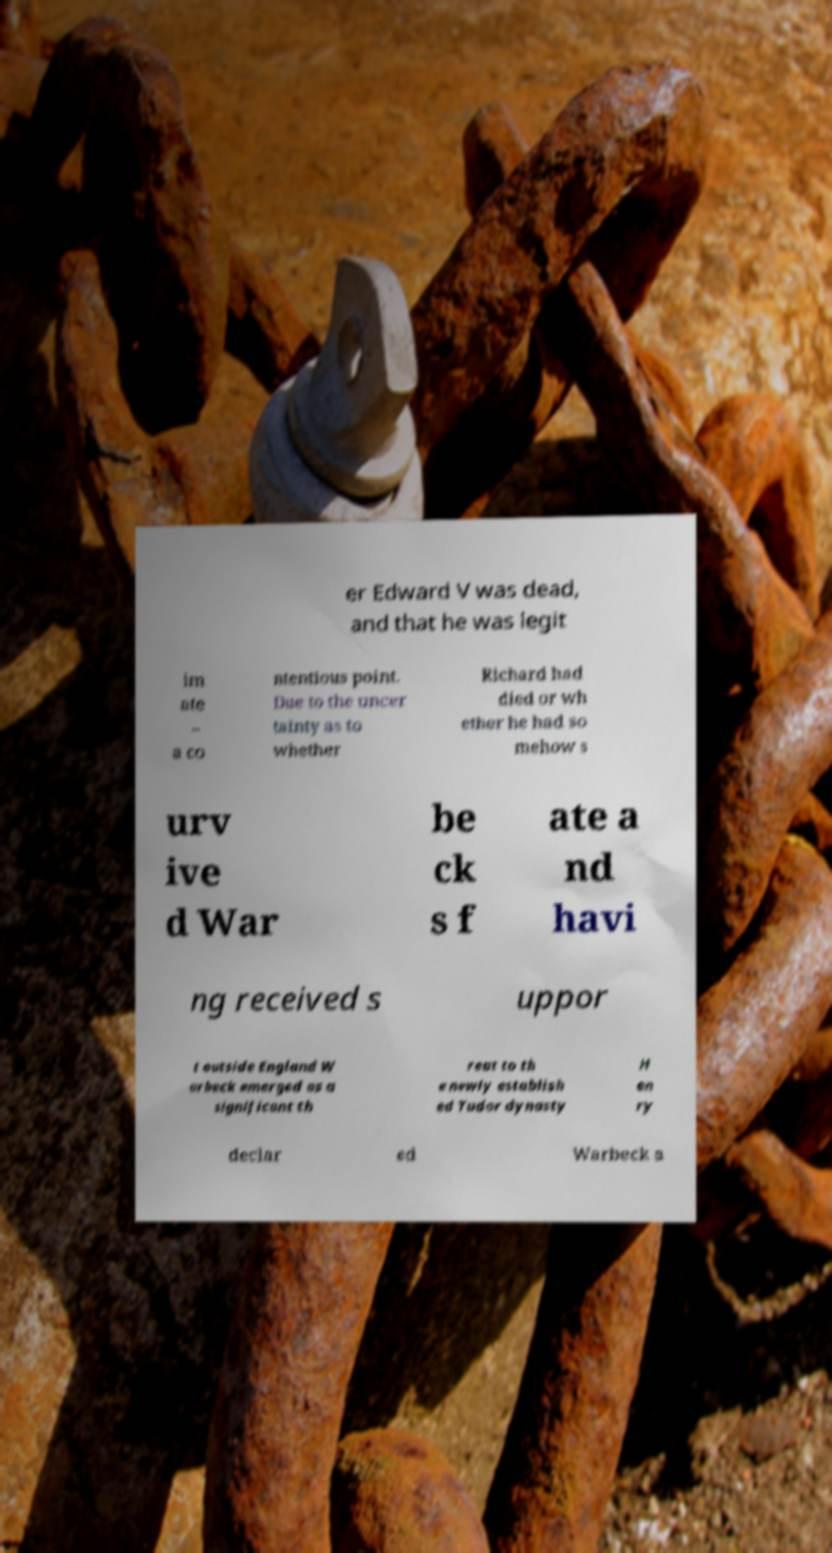Please read and relay the text visible in this image. What does it say? er Edward V was dead, and that he was legit im ate – a co ntentious point. Due to the uncer tainty as to whether Richard had died or wh ether he had so mehow s urv ive d War be ck s f ate a nd havi ng received s uppor t outside England W arbeck emerged as a significant th reat to th e newly establish ed Tudor dynasty H en ry declar ed Warbeck a 